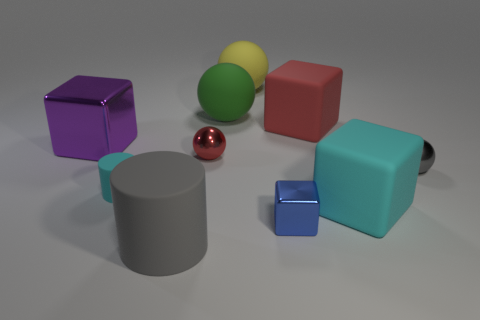Subtract all gray metal balls. How many balls are left? 3 Subtract all cyan cubes. How many cubes are left? 3 Subtract all gray blocks. How many gray cylinders are left? 1 Subtract 1 cyan cubes. How many objects are left? 9 Subtract all cubes. How many objects are left? 6 Subtract 2 spheres. How many spheres are left? 2 Subtract all yellow blocks. Subtract all brown spheres. How many blocks are left? 4 Subtract all big gray shiny spheres. Subtract all small cyan objects. How many objects are left? 9 Add 2 big yellow rubber objects. How many big yellow rubber objects are left? 3 Add 3 big red matte objects. How many big red matte objects exist? 4 